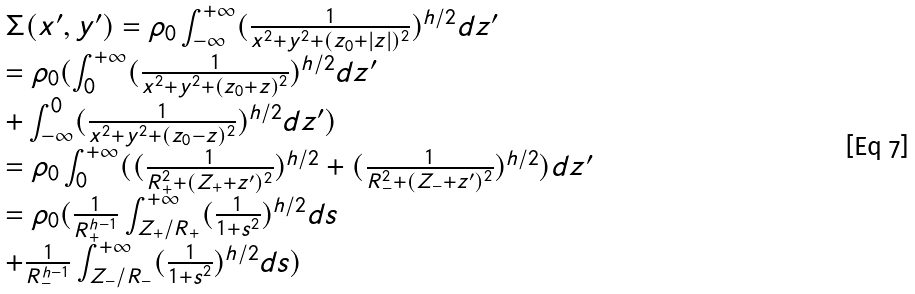Convert formula to latex. <formula><loc_0><loc_0><loc_500><loc_500>\begin{array} { l } \Sigma ( x ^ { \prime } , y ^ { \prime } ) = \rho _ { 0 } \int ^ { + \infty } _ { - \infty } ( \frac { 1 } { x ^ { 2 } + y ^ { 2 } + ( z _ { 0 } + | z | ) ^ { 2 } } ) ^ { h / 2 } d z ^ { \prime } \\ = \rho _ { 0 } ( \int ^ { + \infty } _ { 0 } ( \frac { 1 } { x ^ { 2 } + y ^ { 2 } + ( z _ { 0 } + z ) ^ { 2 } } ) ^ { h / 2 } d z ^ { \prime } \\ + \int ^ { 0 } _ { - \infty } ( \frac { 1 } { x ^ { 2 } + y ^ { 2 } + ( z _ { 0 } - z ) ^ { 2 } } ) ^ { h / 2 } d z ^ { \prime } ) \\ = \rho _ { 0 } \int ^ { + \infty } _ { 0 } ( ( \frac { 1 } { R _ { + } ^ { 2 } + ( Z _ { + } + z ^ { \prime } ) ^ { 2 } } ) ^ { h / 2 } + ( \frac { 1 } { R _ { - } ^ { 2 } + ( Z _ { - } + z ^ { \prime } ) ^ { 2 } } ) ^ { h / 2 } ) d z ^ { \prime } \\ = \rho _ { 0 } ( \frac { 1 } { R ^ { h - 1 } _ { + } } \int ^ { + \infty } _ { Z _ { + } / R _ { + } } ( \frac { 1 } { 1 + s ^ { 2 } } ) ^ { h / 2 } d s \\ + \frac { 1 } { R ^ { h - 1 } _ { - } } \int ^ { + \infty } _ { Z _ { - } / R _ { - } } ( \frac { 1 } { 1 + s ^ { 2 } } ) ^ { h / 2 } d s ) \end{array}</formula> 